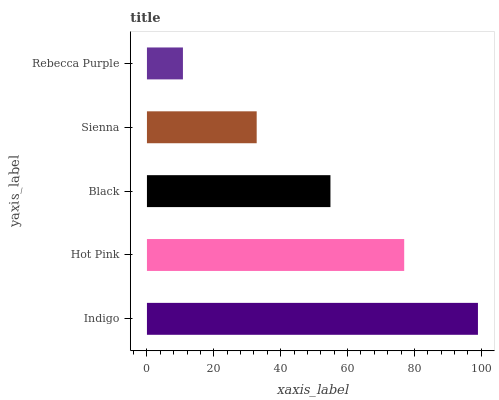Is Rebecca Purple the minimum?
Answer yes or no. Yes. Is Indigo the maximum?
Answer yes or no. Yes. Is Hot Pink the minimum?
Answer yes or no. No. Is Hot Pink the maximum?
Answer yes or no. No. Is Indigo greater than Hot Pink?
Answer yes or no. Yes. Is Hot Pink less than Indigo?
Answer yes or no. Yes. Is Hot Pink greater than Indigo?
Answer yes or no. No. Is Indigo less than Hot Pink?
Answer yes or no. No. Is Black the high median?
Answer yes or no. Yes. Is Black the low median?
Answer yes or no. Yes. Is Indigo the high median?
Answer yes or no. No. Is Hot Pink the low median?
Answer yes or no. No. 